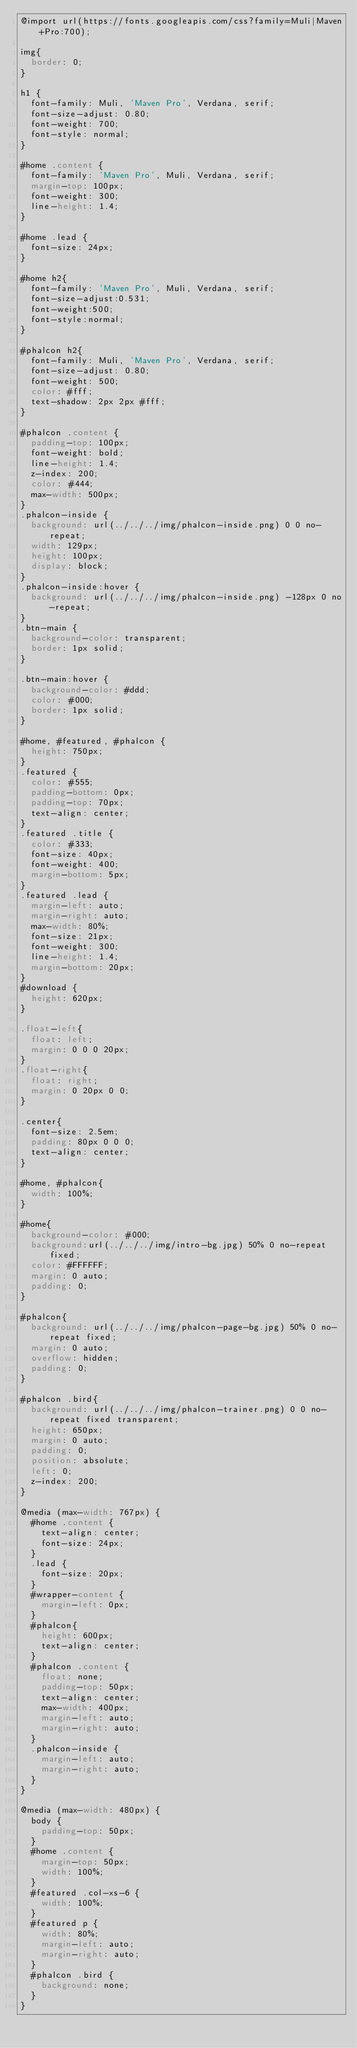<code> <loc_0><loc_0><loc_500><loc_500><_CSS_>@import url(https://fonts.googleapis.com/css?family=Muli|Maven+Pro:700);

img{
	border: 0;
}

h1 {
	font-family: Muli, 'Maven Pro', Verdana, serif;
	font-size-adjust: 0.80;
	font-weight: 700;
	font-style: normal;
}

#home .content {
	font-family: 'Maven Pro', Muli, Verdana, serif;
	margin-top: 100px;
	font-weight: 300;
	line-height: 1.4;
}

#home .lead {
	font-size: 24px;
}

#home h2{
	font-family: 'Maven Pro', Muli, Verdana, serif;
	font-size-adjust:0.531;
	font-weight:500;
	font-style:normal;
}

#phalcon h2{
	font-family: Muli, 'Maven Pro', Verdana, serif;
	font-size-adjust: 0.80;
	font-weight: 500;
	color: #fff;
	text-shadow: 2px 2px #fff;
}

#phalcon .content {
	padding-top: 100px;
	font-weight: bold;
	line-height: 1.4;
	z-index: 200;
	color: #444;
	max-width: 500px;
}
.phalcon-inside {
	background: url(../../../img/phalcon-inside.png) 0 0 no-repeat;
	width: 129px;
	height: 100px;
	display: block;
}
.phalcon-inside:hover {
	background: url(../../../img/phalcon-inside.png) -128px 0 no-repeat;
}
.btn-main {
	background-color: transparent;
	border: 1px solid;
}

.btn-main:hover {
	background-color: #ddd;
	color: #000;
	border: 1px solid;
}

#home, #featured, #phalcon {
	height: 750px;
}
.featured {
	color: #555;
  padding-bottom: 0px;
  padding-top: 70px;
  text-align: center;
}
.featured .title {
  color: #333;
  font-size: 40px;
  font-weight: 400;
  margin-bottom: 5px;
}
.featured .lead {
  margin-left: auto;
  margin-right: auto;
  max-width: 80%;
  font-size: 21px;
  font-weight: 300;
  line-height: 1.4;
  margin-bottom: 20px;
}
#download {
	height: 620px;
}

.float-left{
	float: left;	
	margin: 0 0 0 20px;
}
.float-right{
	float: right;
	margin: 0 20px 0 0;
}

.center{
	font-size: 2.5em;
	padding: 80px 0 0 0;
	text-align: center;
}

#home, #phalcon{
	width: 100%;
}

#home{
	background-color: #000;
	background:url(../../../img/intro-bg.jpg) 50% 0 no-repeat fixed;
	color: #FFFFFF;
	margin: 0 auto;
	padding: 0;
}

#phalcon{
	background: url(../../../img/phalcon-page-bg.jpg) 50% 0 no-repeat fixed;
	margin: 0 auto;
	overflow: hidden;
	padding: 0;
}

#phalcon .bird{
	background: url(../../../img/phalcon-trainer.png) 0 0 no-repeat fixed transparent;
	height: 650px;
	margin: 0 auto;
	padding: 0;
	position: absolute;
	left: 0;
	z-index: 200;
}

@media (max-width: 767px) {
	#home .content {
		text-align: center;
		font-size: 24px;
	}
	.lead {
		font-size: 20px;
	}
	#wrapper-content {
		margin-left: 0px;
	}
	#phalcon{
		height: 600px;
		text-align: center;
	}
	#phalcon .content {
		float: none;
		padding-top: 50px;
		text-align: center;
		max-width: 400px;
		margin-left: auto;
		margin-right: auto;
	}
	.phalcon-inside {
		margin-left: auto;
		margin-right: auto;
	}
}

@media (max-width: 480px) {
	body {
		padding-top: 50px;
	}
	#home .content {
		margin-top: 50px;
		width: 100%;
	}
	#featured .col-xs-6 {
		width: 100%;
	}
	#featured p {
		width: 80%;
    margin-left: auto;
    margin-right: auto;
	}
	#phalcon .bird {
		background: none;
	}
}</code> 